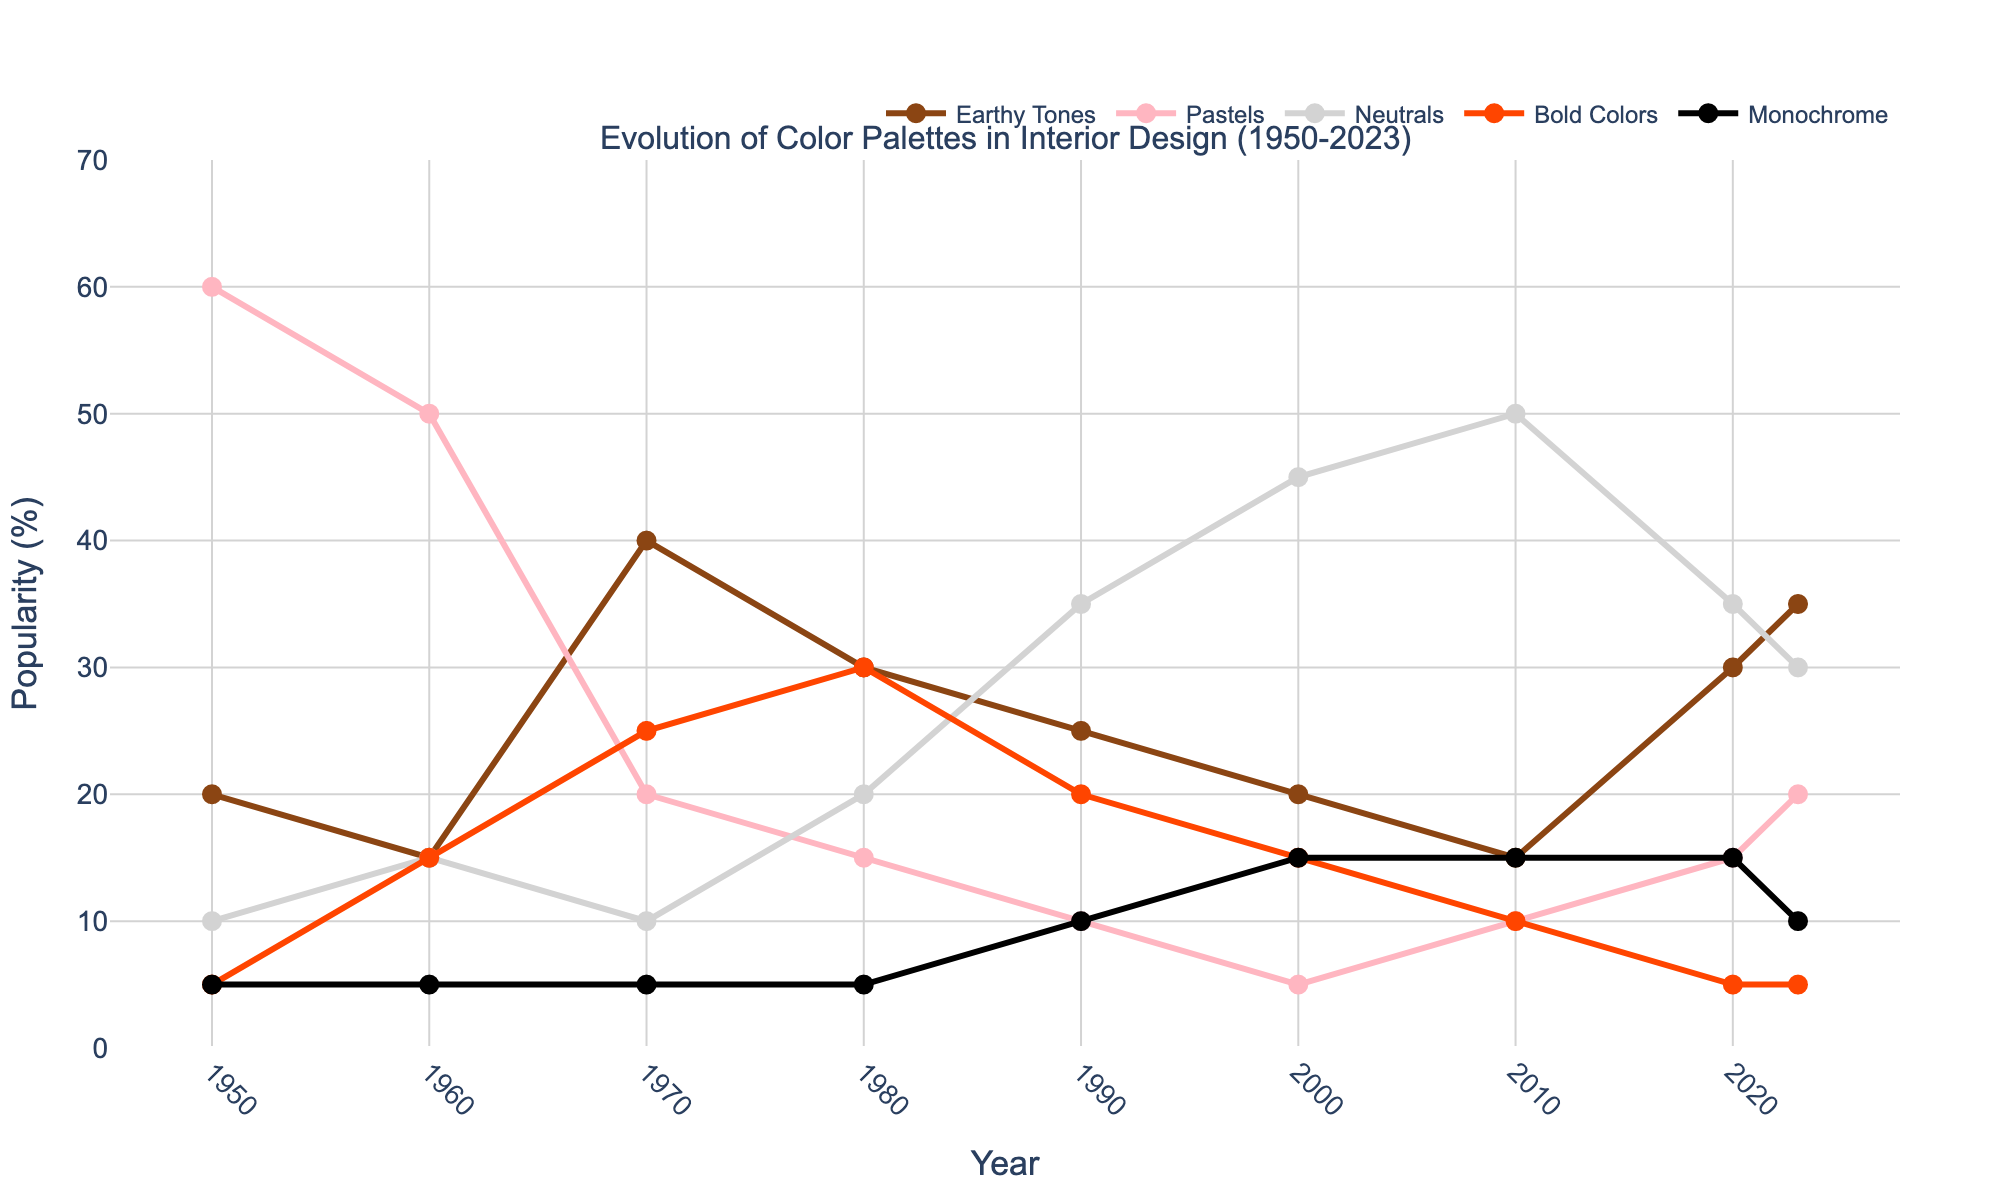What's the most popular color palette in 1970? Look at the year 1970 and identify the line that has the highest value. The Bold Colors line is highest with a value of 25%.
Answer: Bold Colors How did the popularity of Pastels change from 1950 to 2023? Compare the values of Pastels in 1950 and 2023. In 1950, it was at 60% and in 2023 it's at 20%, indicating a decrease in popularity.
Answer: It decreased Which color palette showed the most consistent increase in popularity from 2000 to 2023? Analyze the trends of each color palette from 2000 to 2023. Neutrals increased from 45% in 2000 to 30% in 2023. Earthy Tones increased from 20% in 2000 to 35% in 2023. Earthy Tones showed the most consistent increase.
Answer: Earthy Tones Comparing Neutrals and Monochrome in 2020, which was more popular and by what percentage? Look at the values for Neutrals and Monochrome in 2020. Neutrals are at 35%, and Monochrome is at 15%. The difference is 35% - 15%.
Answer: Neutrals by 20% How did the popularity of Bold Colors change between 1980 and 2000? Compare the values for Bold Colors in 1980 and 2000. In 1980, it was 30%, and in 2000, it was 15%. This indicates a decrease in popularity by 15%.
Answer: It decreased by 15% Which color palette peaked in the 1960s and what was its peak value? Look at the decade 1960 and identify which line has the highest value. Pastels peaked at 50% in the 1960s.
Answer: Pastels, 50% In what year did Earthy Tones surpass Pastels in popularity? Identify the point where the Earthy Tones line crosses above the Pastels line. In 1970, Earthy Tones at 40% surpassed Pastels at 20%.
Answer: 1970 Calculate the average popularity of Neutrals from 1950 to 2023. Sum the values of Neutrals (10 + 15 + 10 + 20 + 35 + 45 + 50 + 35 + 30) and divide by the number of years included (9). The total is 250, and the average is 250/9 ≈ 27.78.
Answer: ~27.78 Was there any color palette that stayed the same popularity percentage across two consecutive periods? Check for flat segments in each line. Monochrome had identical values of 15% in both 2010 and 2020.
Answer: Yes, Monochrome (2010-2020) 